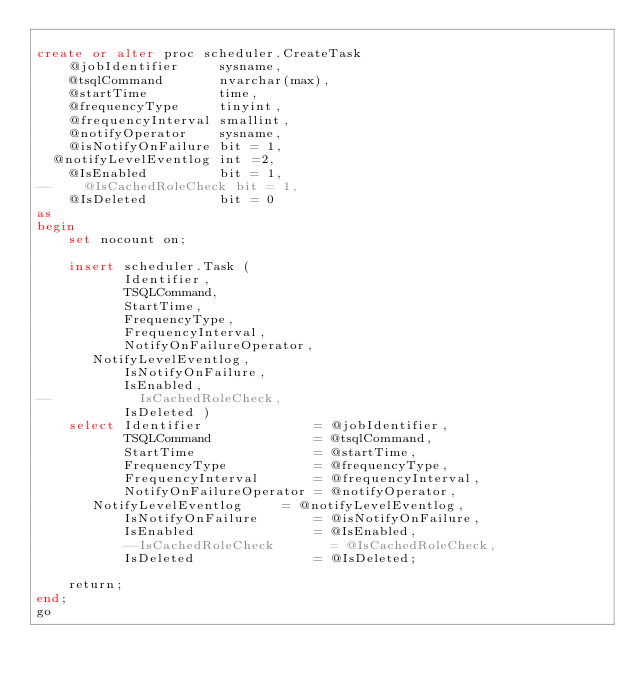<code> <loc_0><loc_0><loc_500><loc_500><_SQL_>
create or alter proc scheduler.CreateTask  
    @jobIdentifier     sysname,
    @tsqlCommand       nvarchar(max),
    @startTime         time,
    @frequencyType     tinyint,
    @frequencyInterval smallint,
    @notifyOperator    sysname,
    @isNotifyOnFailure bit = 1,
	@notifyLevelEventlog int =2,
    @IsEnabled         bit = 1,
--    @IsCachedRoleCheck bit = 1,
    @IsDeleted         bit = 0
as
begin
    set nocount on;

    insert scheduler.Task ( 
           Identifier,
           TSQLCommand,
           StartTime,
           FrequencyType,
           FrequencyInterval,
           NotifyOnFailureOperator,
		   NotifyLevelEventlog,
           IsNotifyOnFailure,
           IsEnabled,
--           IsCachedRoleCheck, 
           IsDeleted )
    select Identifier              = @jobIdentifier,
           TSQLCommand             = @tsqlCommand,
           StartTime               = @startTime,
           FrequencyType           = @frequencyType,
           FrequencyInterval       = @frequencyInterval,
           NotifyOnFailureOperator = @notifyOperator,
		   NotifyLevelEventlog	   = @notifyLevelEventlog,
           IsNotifyOnFailure       = @isNotifyOnFailure,
           IsEnabled               = @IsEnabled,
           --IsCachedRoleCheck       = @IsCachedRoleCheck,
           IsDeleted               = @IsDeleted;
    
    return;
end;
go
</code> 